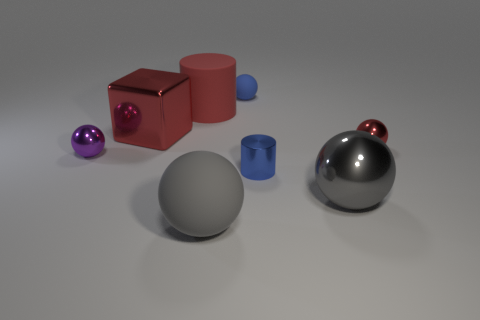Subtract all red balls. How many balls are left? 4 Subtract all blue balls. How many balls are left? 4 Subtract all green balls. Subtract all blue cylinders. How many balls are left? 5 Add 2 tiny purple objects. How many objects exist? 10 Subtract all cubes. How many objects are left? 7 Subtract 1 red spheres. How many objects are left? 7 Subtract all tiny things. Subtract all big gray things. How many objects are left? 2 Add 7 big gray spheres. How many big gray spheres are left? 9 Add 6 blue matte blocks. How many blue matte blocks exist? 6 